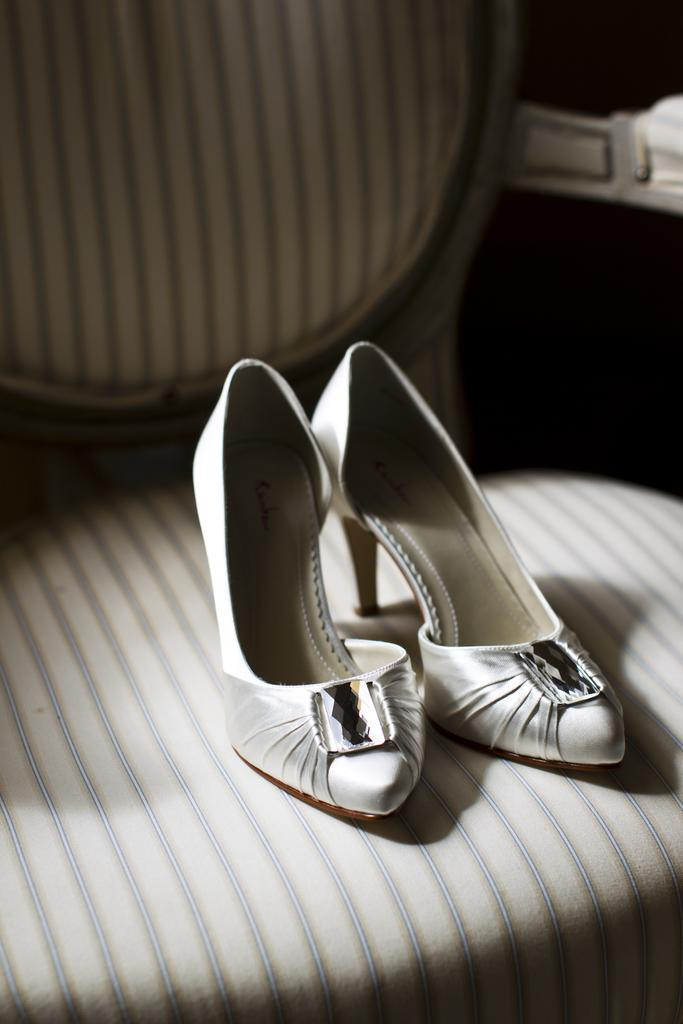What is the main subject of the image? The main subject of the image is a pair of shoes. Where are the shoes located in the image? The shoes are in the center of the image. What is the shoes resting on in the image? The shoes are on a chair. What type of copper material is used to make the sink in the image? There is no sink or copper material present in the image; it features a pair of shoes on a chair. 